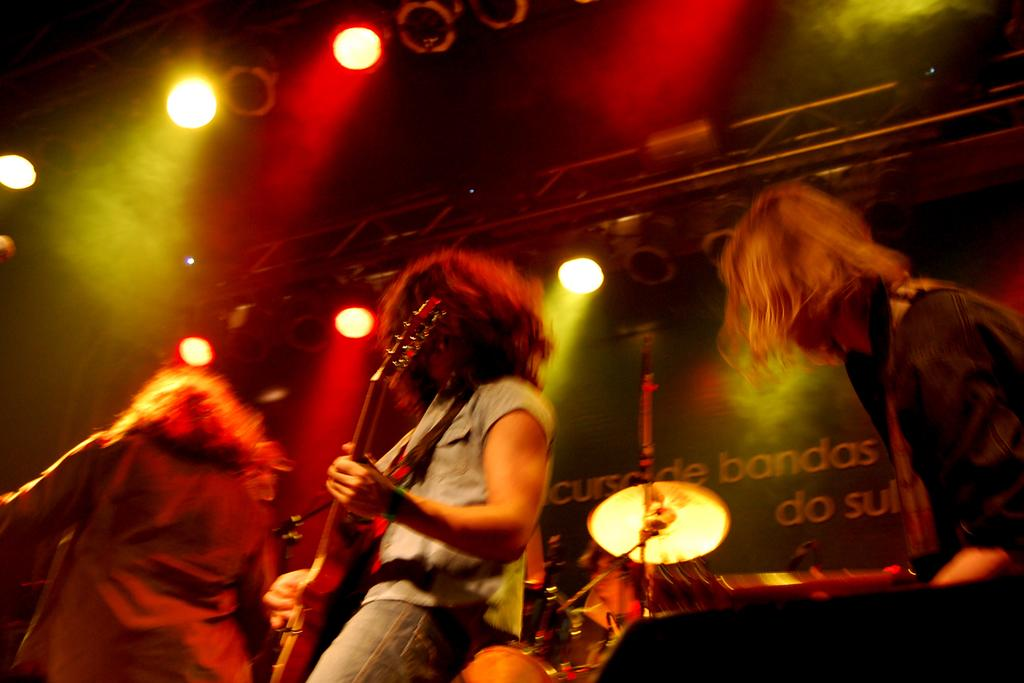How many people are in the image? There are three persons in the image. What is one of the persons holding? One of the persons is holding a guitar. What can be seen in the background of the image? There are lights visible in the background of the image. Can you describe the musical instrument in the background? Unfortunately, the provided facts do not give enough information to describe the musical instrument in the background. What type of leather is being used to make the cabbage in the image? There is no leather or cabbage present in the image. 